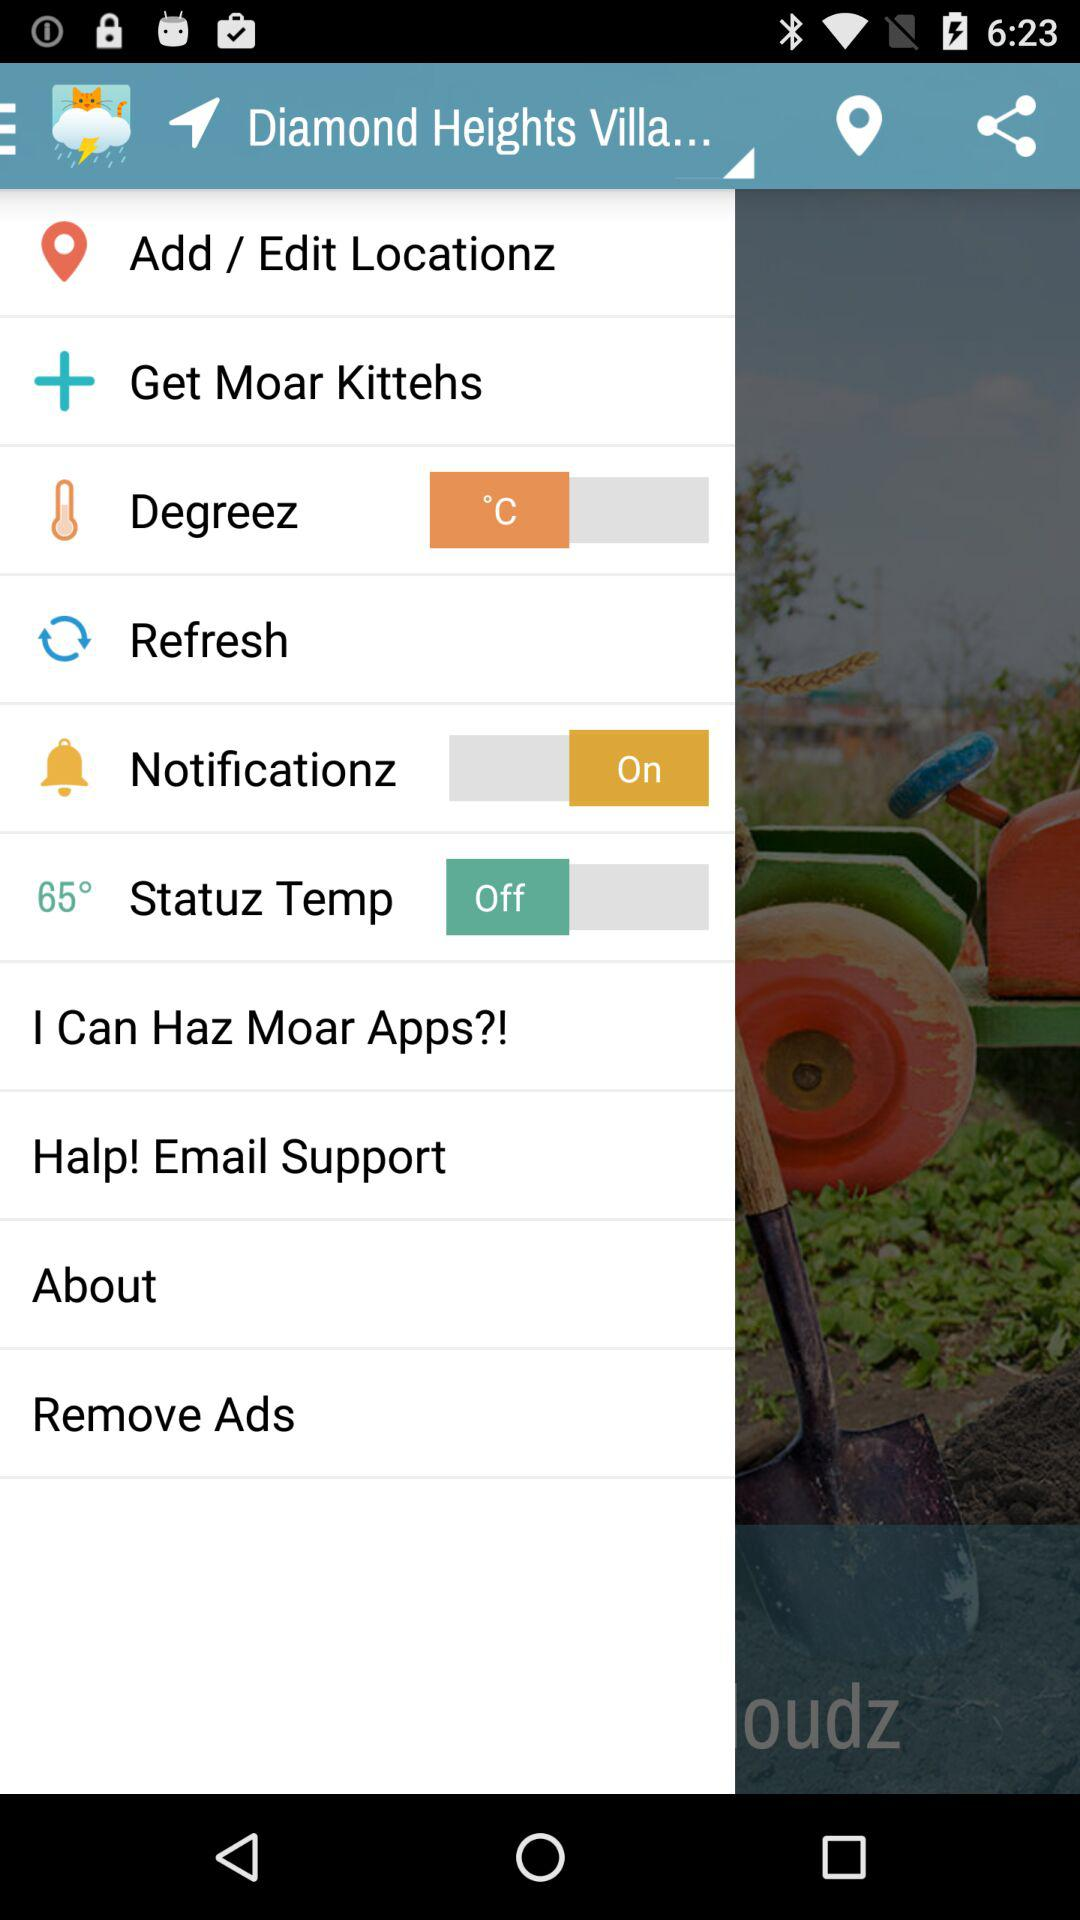What is the location mentioned? The location is "Diamond Heights Villa...". 